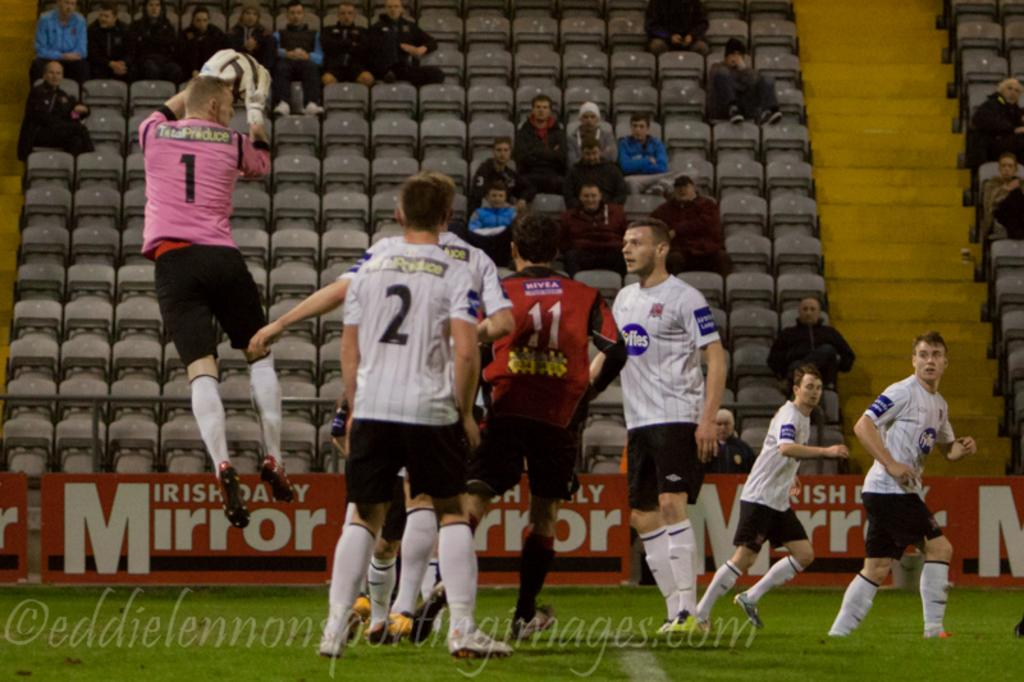Provide a one-sentence caption for the provided image. a soccer field with a player wearing the number 2. 